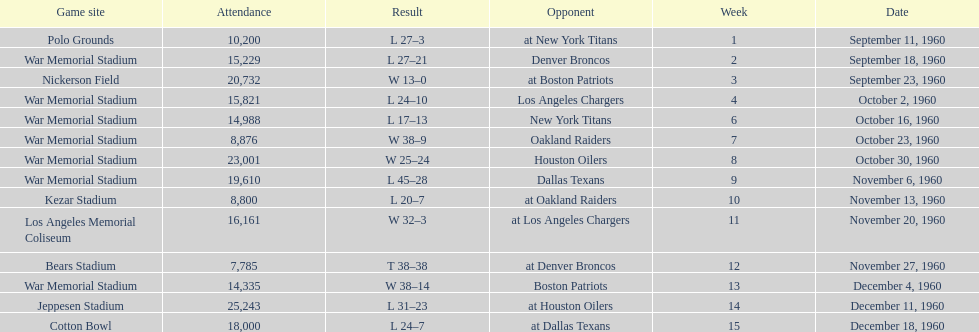Who did the bills play after the oakland raiders? Houston Oilers. 